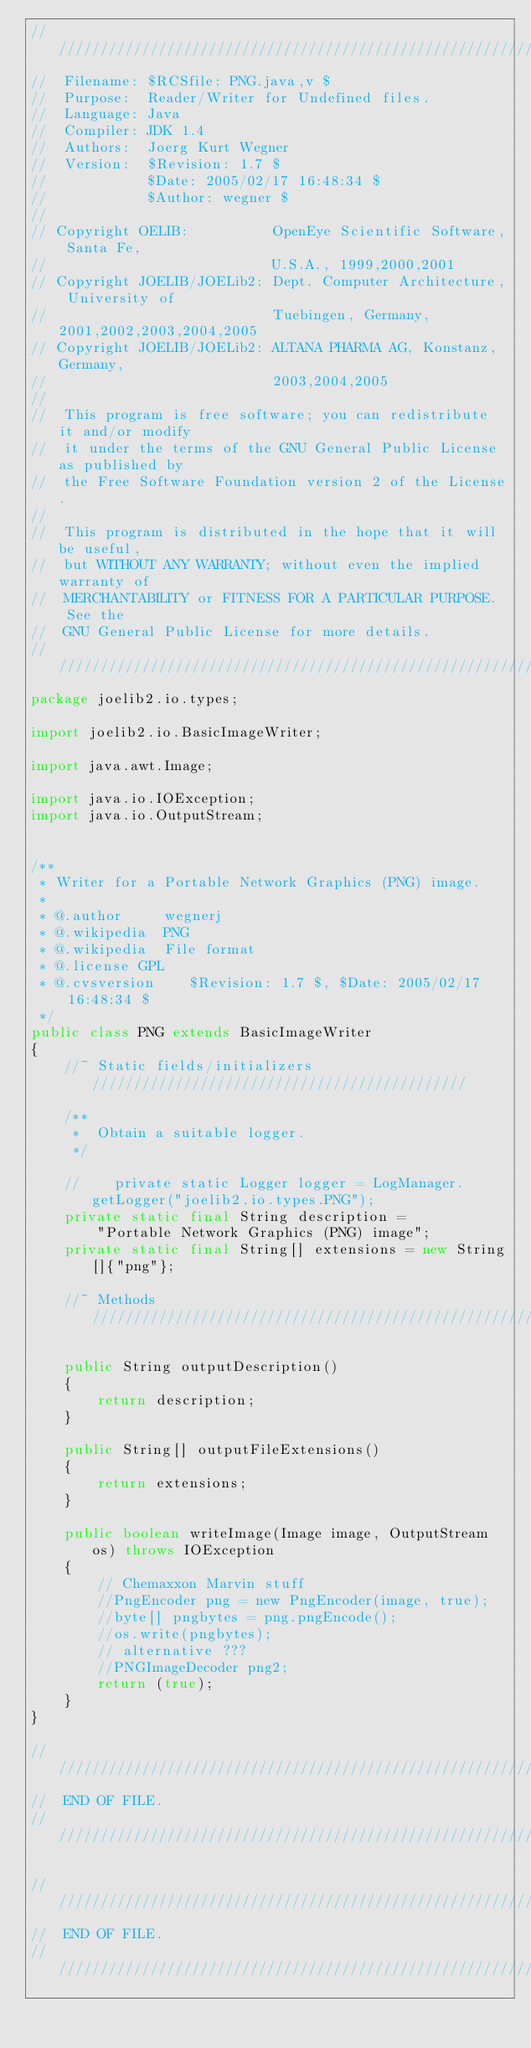Convert code to text. <code><loc_0><loc_0><loc_500><loc_500><_Java_>///////////////////////////////////////////////////////////////////////////////
//  Filename: $RCSfile: PNG.java,v $
//  Purpose:  Reader/Writer for Undefined files.
//  Language: Java
//  Compiler: JDK 1.4
//  Authors:  Joerg Kurt Wegner
//  Version:  $Revision: 1.7 $
//            $Date: 2005/02/17 16:48:34 $
//            $Author: wegner $
//
// Copyright OELIB:          OpenEye Scientific Software, Santa Fe,
//                           U.S.A., 1999,2000,2001
// Copyright JOELIB/JOELib2: Dept. Computer Architecture, University of
//                           Tuebingen, Germany, 2001,2002,2003,2004,2005
// Copyright JOELIB/JOELib2: ALTANA PHARMA AG, Konstanz, Germany,
//                           2003,2004,2005
//
//  This program is free software; you can redistribute it and/or modify
//  it under the terms of the GNU General Public License as published by
//  the Free Software Foundation version 2 of the License.
//
//  This program is distributed in the hope that it will be useful,
//  but WITHOUT ANY WARRANTY; without even the implied warranty of
//  MERCHANTABILITY or FITNESS FOR A PARTICULAR PURPOSE.  See the
//  GNU General Public License for more details.
///////////////////////////////////////////////////////////////////////////////
package joelib2.io.types;

import joelib2.io.BasicImageWriter;

import java.awt.Image;

import java.io.IOException;
import java.io.OutputStream;


/**
 * Writer for a Portable Network Graphics (PNG) image.
 *
 * @.author     wegnerj
 * @.wikipedia  PNG
 * @.wikipedia  File format
 * @.license GPL
 * @.cvsversion    $Revision: 1.7 $, $Date: 2005/02/17 16:48:34 $
 */
public class PNG extends BasicImageWriter
{
    //~ Static fields/initializers /////////////////////////////////////////////

    /**
     *  Obtain a suitable logger.
     */

    //    private static Logger logger = LogManager.getLogger("joelib2.io.types.PNG");
    private static final String description =
        "Portable Network Graphics (PNG) image";
    private static final String[] extensions = new String[]{"png"};

    //~ Methods ////////////////////////////////////////////////////////////////

    public String outputDescription()
    {
        return description;
    }

    public String[] outputFileExtensions()
    {
        return extensions;
    }

    public boolean writeImage(Image image, OutputStream os) throws IOException
    {
        // Chemaxxon Marvin stuff
        //PngEncoder png = new PngEncoder(image, true);
        //byte[] pngbytes = png.pngEncode();
        //os.write(pngbytes);
        // alternative ???
        //PNGImageDecoder png2;
        return (true);
    }
}

///////////////////////////////////////////////////////////////////////////////
//  END OF FILE.
///////////////////////////////////////////////////////////////////////////////

///////////////////////////////////////////////////////////////////////////////
//  END OF FILE.
///////////////////////////////////////////////////////////////////////////////
</code> 